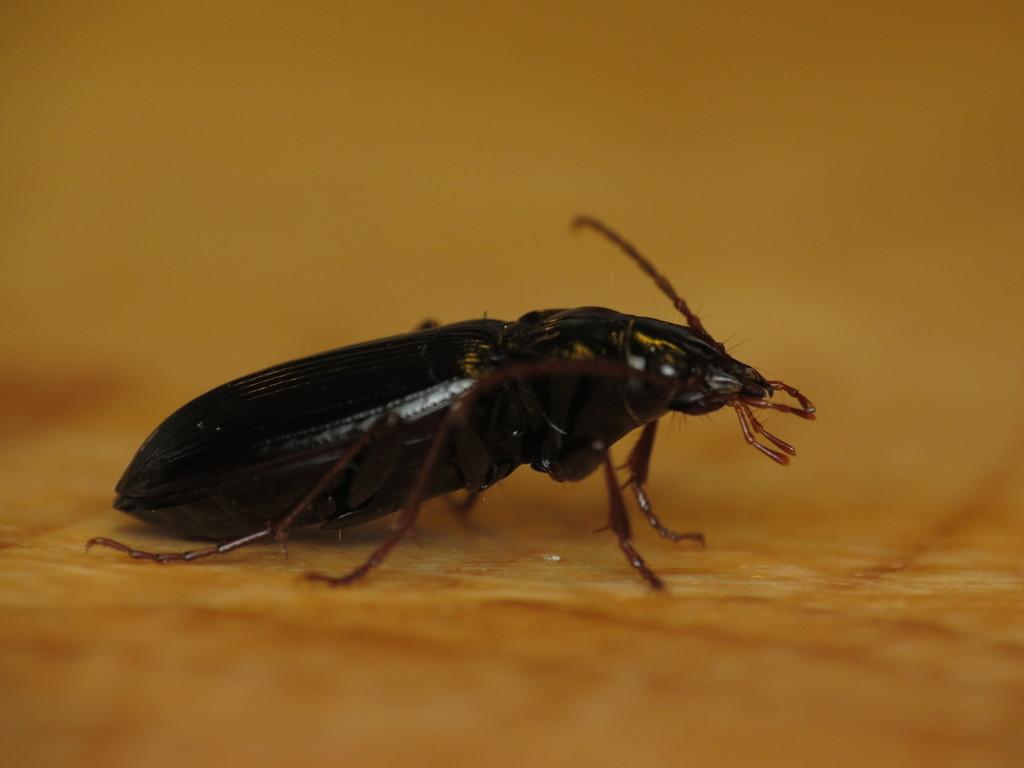What type of creature is present in the image? There is an insect in the image. What type of trip is the insect planning to take in the image? There is no indication of a trip or any travel-related activities in the image. The insect is simply present in the image. 